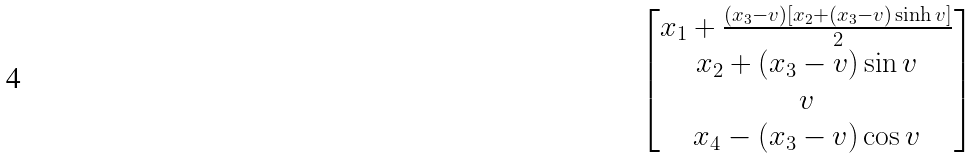Convert formula to latex. <formula><loc_0><loc_0><loc_500><loc_500>\begin{bmatrix} x _ { 1 } + \frac { ( x _ { 3 } - v ) [ x _ { 2 } + ( x _ { 3 } - v ) \sinh v ] } { 2 } \\ x _ { 2 } + ( x _ { 3 } - v ) \sin v \\ v \\ x _ { 4 } - ( x _ { 3 } - v ) \cos v \end{bmatrix}</formula> 